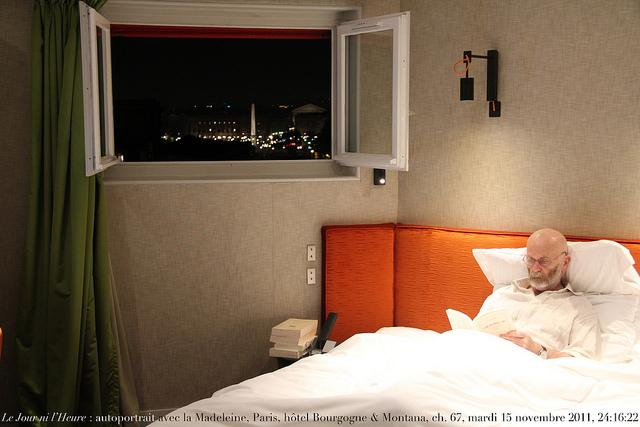Why does he need the light to be on? reading 